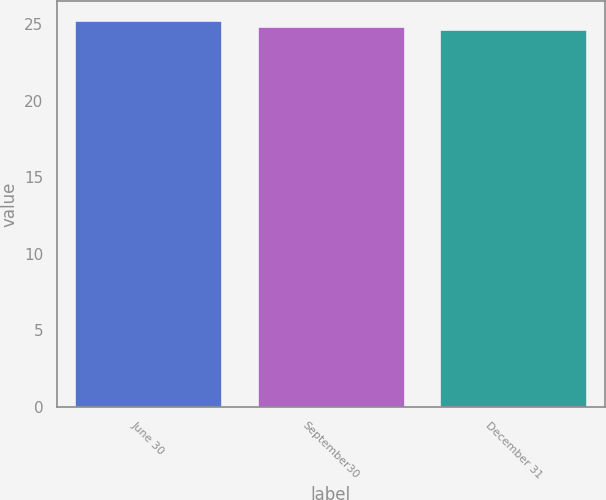<chart> <loc_0><loc_0><loc_500><loc_500><bar_chart><fcel>June 30<fcel>September30<fcel>December 31<nl><fcel>25.21<fcel>24.79<fcel>24.6<nl></chart> 